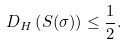<formula> <loc_0><loc_0><loc_500><loc_500>D _ { H } \left ( S ( \sigma ) \right ) \leq \frac { 1 } { 2 } .</formula> 